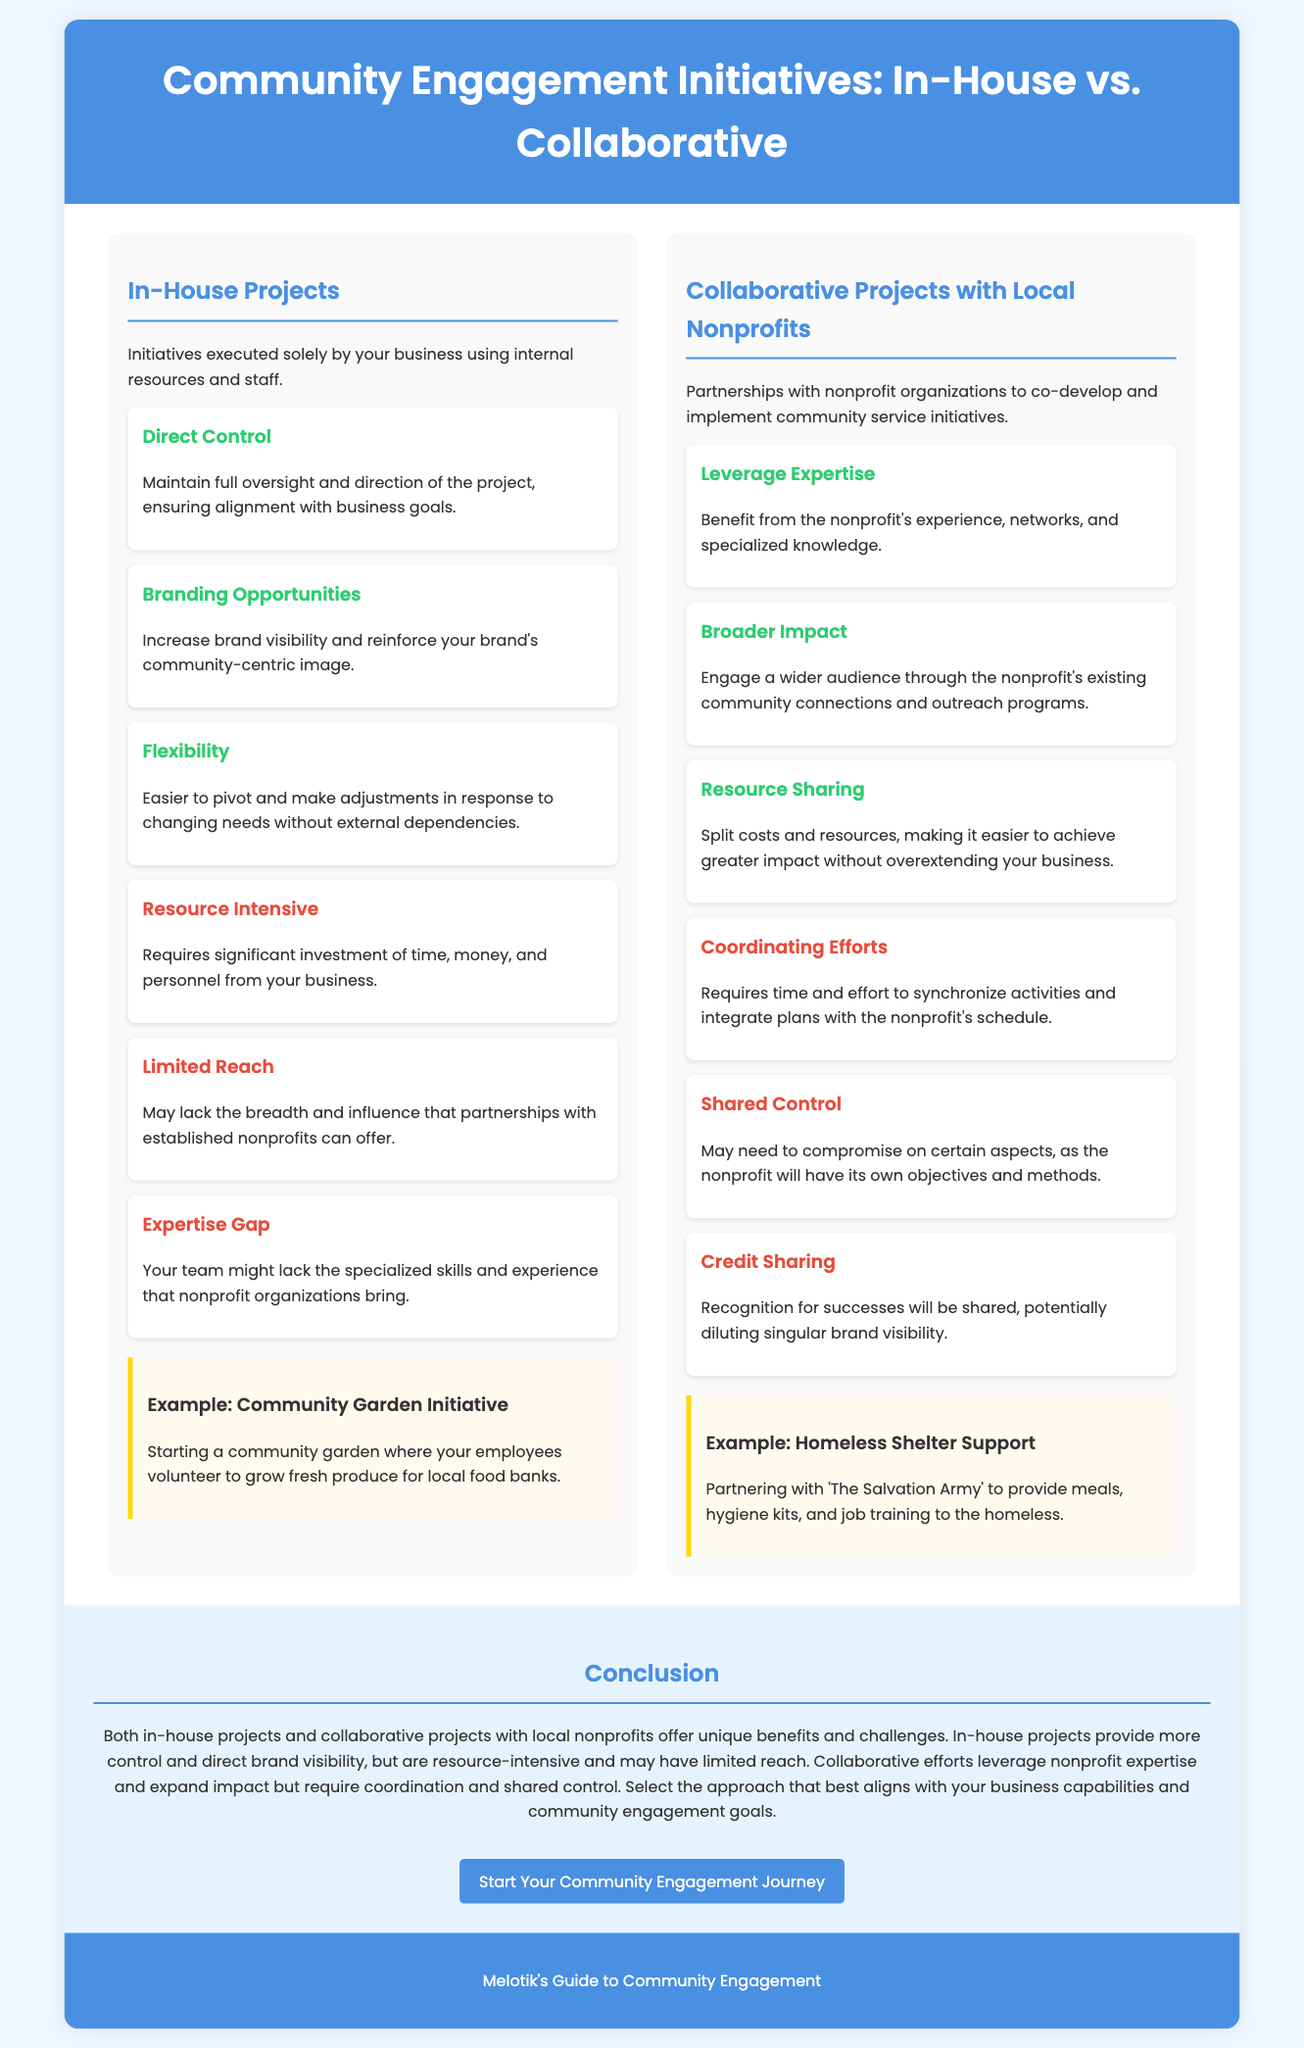What are in-house projects? In-house projects are initiatives executed solely by your business using internal resources and staff.
Answer: Initiatives executed solely by your business using internal resources and staff What is one benefit of collaborative projects with local nonprofits? One benefit is leveraging the nonprofit's experience, networks, and specialized knowledge.
Answer: Leverage Expertise What is a challenge of in-house projects? One challenge is that it requires significant investment of time, money, and personnel from your business.
Answer: Resource Intensive What example is given for in-house projects? The example given is starting a community garden where employees volunteer to grow fresh produce for local food banks.
Answer: Community Garden Initiative How many advantages are listed for collaborative projects with local nonprofits? There are three advantages listed for collaborative projects.
Answer: Three What is a shared challenge in collaborative projects? A shared challenge is that recognition for successes will be shared, potentially diluting singular brand visibility.
Answer: Credit Sharing What is the main purpose of the infographic? The main purpose is to compare in-house projects and collaborative projects with local nonprofits.
Answer: Compare in-house and collaborative projects What type of engagement do in-house projects provide? In-house projects provide more control and direct brand visibility.
Answer: More control and direct brand visibility 